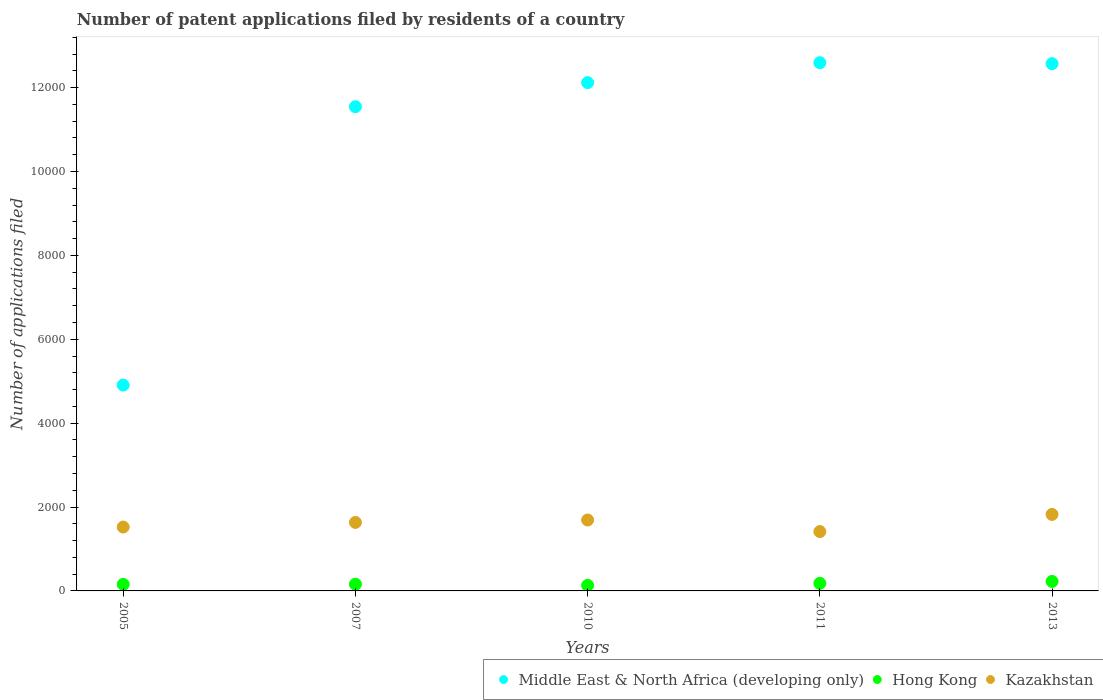How many different coloured dotlines are there?
Keep it short and to the point. 3. What is the number of applications filed in Middle East & North Africa (developing only) in 2011?
Your answer should be very brief. 1.26e+04. Across all years, what is the maximum number of applications filed in Kazakhstan?
Keep it short and to the point. 1824. Across all years, what is the minimum number of applications filed in Kazakhstan?
Keep it short and to the point. 1415. In which year was the number of applications filed in Kazakhstan minimum?
Provide a short and direct response. 2011. What is the total number of applications filed in Hong Kong in the graph?
Ensure brevity in your answer.  856. What is the difference between the number of applications filed in Middle East & North Africa (developing only) in 2013 and the number of applications filed in Hong Kong in 2005?
Provide a succinct answer. 1.24e+04. What is the average number of applications filed in Middle East & North Africa (developing only) per year?
Your answer should be very brief. 1.07e+04. In the year 2007, what is the difference between the number of applications filed in Kazakhstan and number of applications filed in Hong Kong?
Offer a terse response. 1473. What is the ratio of the number of applications filed in Hong Kong in 2010 to that in 2013?
Your answer should be very brief. 0.59. Is the number of applications filed in Middle East & North Africa (developing only) in 2007 less than that in 2011?
Your response must be concise. Yes. What is the difference between the highest and the second highest number of applications filed in Kazakhstan?
Provide a succinct answer. 133. What is the difference between the highest and the lowest number of applications filed in Middle East & North Africa (developing only)?
Provide a succinct answer. 7686. Is the sum of the number of applications filed in Hong Kong in 2011 and 2013 greater than the maximum number of applications filed in Kazakhstan across all years?
Your answer should be compact. No. Is the number of applications filed in Kazakhstan strictly greater than the number of applications filed in Hong Kong over the years?
Make the answer very short. Yes. Is the number of applications filed in Middle East & North Africa (developing only) strictly less than the number of applications filed in Hong Kong over the years?
Your answer should be compact. No. How many years are there in the graph?
Your answer should be very brief. 5. Are the values on the major ticks of Y-axis written in scientific E-notation?
Keep it short and to the point. No. Does the graph contain any zero values?
Your answer should be compact. No. Does the graph contain grids?
Your answer should be compact. No. Where does the legend appear in the graph?
Your answer should be compact. Bottom right. How many legend labels are there?
Make the answer very short. 3. How are the legend labels stacked?
Give a very brief answer. Horizontal. What is the title of the graph?
Provide a succinct answer. Number of patent applications filed by residents of a country. What is the label or title of the Y-axis?
Ensure brevity in your answer.  Number of applications filed. What is the Number of applications filed of Middle East & North Africa (developing only) in 2005?
Ensure brevity in your answer.  4908. What is the Number of applications filed in Hong Kong in 2005?
Your answer should be compact. 156. What is the Number of applications filed of Kazakhstan in 2005?
Your answer should be compact. 1523. What is the Number of applications filed of Middle East & North Africa (developing only) in 2007?
Keep it short and to the point. 1.15e+04. What is the Number of applications filed in Hong Kong in 2007?
Ensure brevity in your answer.  160. What is the Number of applications filed of Kazakhstan in 2007?
Offer a terse response. 1633. What is the Number of applications filed in Middle East & North Africa (developing only) in 2010?
Make the answer very short. 1.21e+04. What is the Number of applications filed in Hong Kong in 2010?
Provide a succinct answer. 133. What is the Number of applications filed in Kazakhstan in 2010?
Ensure brevity in your answer.  1691. What is the Number of applications filed in Middle East & North Africa (developing only) in 2011?
Provide a short and direct response. 1.26e+04. What is the Number of applications filed of Hong Kong in 2011?
Your answer should be compact. 181. What is the Number of applications filed in Kazakhstan in 2011?
Give a very brief answer. 1415. What is the Number of applications filed of Middle East & North Africa (developing only) in 2013?
Give a very brief answer. 1.26e+04. What is the Number of applications filed of Hong Kong in 2013?
Your answer should be compact. 226. What is the Number of applications filed in Kazakhstan in 2013?
Your answer should be very brief. 1824. Across all years, what is the maximum Number of applications filed of Middle East & North Africa (developing only)?
Provide a succinct answer. 1.26e+04. Across all years, what is the maximum Number of applications filed of Hong Kong?
Your answer should be compact. 226. Across all years, what is the maximum Number of applications filed of Kazakhstan?
Provide a short and direct response. 1824. Across all years, what is the minimum Number of applications filed in Middle East & North Africa (developing only)?
Offer a terse response. 4908. Across all years, what is the minimum Number of applications filed of Hong Kong?
Keep it short and to the point. 133. Across all years, what is the minimum Number of applications filed of Kazakhstan?
Make the answer very short. 1415. What is the total Number of applications filed in Middle East & North Africa (developing only) in the graph?
Your response must be concise. 5.37e+04. What is the total Number of applications filed of Hong Kong in the graph?
Provide a short and direct response. 856. What is the total Number of applications filed of Kazakhstan in the graph?
Make the answer very short. 8086. What is the difference between the Number of applications filed in Middle East & North Africa (developing only) in 2005 and that in 2007?
Provide a short and direct response. -6636. What is the difference between the Number of applications filed in Kazakhstan in 2005 and that in 2007?
Ensure brevity in your answer.  -110. What is the difference between the Number of applications filed of Middle East & North Africa (developing only) in 2005 and that in 2010?
Ensure brevity in your answer.  -7211. What is the difference between the Number of applications filed of Kazakhstan in 2005 and that in 2010?
Make the answer very short. -168. What is the difference between the Number of applications filed of Middle East & North Africa (developing only) in 2005 and that in 2011?
Provide a short and direct response. -7686. What is the difference between the Number of applications filed of Kazakhstan in 2005 and that in 2011?
Make the answer very short. 108. What is the difference between the Number of applications filed of Middle East & North Africa (developing only) in 2005 and that in 2013?
Your answer should be compact. -7663. What is the difference between the Number of applications filed of Hong Kong in 2005 and that in 2013?
Your response must be concise. -70. What is the difference between the Number of applications filed of Kazakhstan in 2005 and that in 2013?
Provide a succinct answer. -301. What is the difference between the Number of applications filed in Middle East & North Africa (developing only) in 2007 and that in 2010?
Ensure brevity in your answer.  -575. What is the difference between the Number of applications filed in Kazakhstan in 2007 and that in 2010?
Your answer should be very brief. -58. What is the difference between the Number of applications filed in Middle East & North Africa (developing only) in 2007 and that in 2011?
Provide a succinct answer. -1050. What is the difference between the Number of applications filed of Kazakhstan in 2007 and that in 2011?
Keep it short and to the point. 218. What is the difference between the Number of applications filed in Middle East & North Africa (developing only) in 2007 and that in 2013?
Provide a short and direct response. -1027. What is the difference between the Number of applications filed of Hong Kong in 2007 and that in 2013?
Your answer should be compact. -66. What is the difference between the Number of applications filed of Kazakhstan in 2007 and that in 2013?
Ensure brevity in your answer.  -191. What is the difference between the Number of applications filed of Middle East & North Africa (developing only) in 2010 and that in 2011?
Offer a very short reply. -475. What is the difference between the Number of applications filed in Hong Kong in 2010 and that in 2011?
Ensure brevity in your answer.  -48. What is the difference between the Number of applications filed in Kazakhstan in 2010 and that in 2011?
Provide a succinct answer. 276. What is the difference between the Number of applications filed of Middle East & North Africa (developing only) in 2010 and that in 2013?
Provide a short and direct response. -452. What is the difference between the Number of applications filed in Hong Kong in 2010 and that in 2013?
Give a very brief answer. -93. What is the difference between the Number of applications filed in Kazakhstan in 2010 and that in 2013?
Make the answer very short. -133. What is the difference between the Number of applications filed of Middle East & North Africa (developing only) in 2011 and that in 2013?
Ensure brevity in your answer.  23. What is the difference between the Number of applications filed in Hong Kong in 2011 and that in 2013?
Provide a short and direct response. -45. What is the difference between the Number of applications filed in Kazakhstan in 2011 and that in 2013?
Provide a short and direct response. -409. What is the difference between the Number of applications filed of Middle East & North Africa (developing only) in 2005 and the Number of applications filed of Hong Kong in 2007?
Give a very brief answer. 4748. What is the difference between the Number of applications filed in Middle East & North Africa (developing only) in 2005 and the Number of applications filed in Kazakhstan in 2007?
Your answer should be compact. 3275. What is the difference between the Number of applications filed of Hong Kong in 2005 and the Number of applications filed of Kazakhstan in 2007?
Provide a succinct answer. -1477. What is the difference between the Number of applications filed of Middle East & North Africa (developing only) in 2005 and the Number of applications filed of Hong Kong in 2010?
Make the answer very short. 4775. What is the difference between the Number of applications filed in Middle East & North Africa (developing only) in 2005 and the Number of applications filed in Kazakhstan in 2010?
Provide a short and direct response. 3217. What is the difference between the Number of applications filed of Hong Kong in 2005 and the Number of applications filed of Kazakhstan in 2010?
Your answer should be compact. -1535. What is the difference between the Number of applications filed of Middle East & North Africa (developing only) in 2005 and the Number of applications filed of Hong Kong in 2011?
Keep it short and to the point. 4727. What is the difference between the Number of applications filed in Middle East & North Africa (developing only) in 2005 and the Number of applications filed in Kazakhstan in 2011?
Provide a succinct answer. 3493. What is the difference between the Number of applications filed in Hong Kong in 2005 and the Number of applications filed in Kazakhstan in 2011?
Your response must be concise. -1259. What is the difference between the Number of applications filed in Middle East & North Africa (developing only) in 2005 and the Number of applications filed in Hong Kong in 2013?
Your answer should be compact. 4682. What is the difference between the Number of applications filed in Middle East & North Africa (developing only) in 2005 and the Number of applications filed in Kazakhstan in 2013?
Ensure brevity in your answer.  3084. What is the difference between the Number of applications filed in Hong Kong in 2005 and the Number of applications filed in Kazakhstan in 2013?
Give a very brief answer. -1668. What is the difference between the Number of applications filed in Middle East & North Africa (developing only) in 2007 and the Number of applications filed in Hong Kong in 2010?
Provide a succinct answer. 1.14e+04. What is the difference between the Number of applications filed of Middle East & North Africa (developing only) in 2007 and the Number of applications filed of Kazakhstan in 2010?
Provide a short and direct response. 9853. What is the difference between the Number of applications filed of Hong Kong in 2007 and the Number of applications filed of Kazakhstan in 2010?
Offer a terse response. -1531. What is the difference between the Number of applications filed of Middle East & North Africa (developing only) in 2007 and the Number of applications filed of Hong Kong in 2011?
Your answer should be compact. 1.14e+04. What is the difference between the Number of applications filed of Middle East & North Africa (developing only) in 2007 and the Number of applications filed of Kazakhstan in 2011?
Provide a short and direct response. 1.01e+04. What is the difference between the Number of applications filed of Hong Kong in 2007 and the Number of applications filed of Kazakhstan in 2011?
Offer a terse response. -1255. What is the difference between the Number of applications filed of Middle East & North Africa (developing only) in 2007 and the Number of applications filed of Hong Kong in 2013?
Provide a succinct answer. 1.13e+04. What is the difference between the Number of applications filed of Middle East & North Africa (developing only) in 2007 and the Number of applications filed of Kazakhstan in 2013?
Give a very brief answer. 9720. What is the difference between the Number of applications filed in Hong Kong in 2007 and the Number of applications filed in Kazakhstan in 2013?
Offer a terse response. -1664. What is the difference between the Number of applications filed in Middle East & North Africa (developing only) in 2010 and the Number of applications filed in Hong Kong in 2011?
Your answer should be very brief. 1.19e+04. What is the difference between the Number of applications filed of Middle East & North Africa (developing only) in 2010 and the Number of applications filed of Kazakhstan in 2011?
Offer a very short reply. 1.07e+04. What is the difference between the Number of applications filed in Hong Kong in 2010 and the Number of applications filed in Kazakhstan in 2011?
Ensure brevity in your answer.  -1282. What is the difference between the Number of applications filed in Middle East & North Africa (developing only) in 2010 and the Number of applications filed in Hong Kong in 2013?
Give a very brief answer. 1.19e+04. What is the difference between the Number of applications filed of Middle East & North Africa (developing only) in 2010 and the Number of applications filed of Kazakhstan in 2013?
Offer a very short reply. 1.03e+04. What is the difference between the Number of applications filed of Hong Kong in 2010 and the Number of applications filed of Kazakhstan in 2013?
Ensure brevity in your answer.  -1691. What is the difference between the Number of applications filed of Middle East & North Africa (developing only) in 2011 and the Number of applications filed of Hong Kong in 2013?
Your response must be concise. 1.24e+04. What is the difference between the Number of applications filed of Middle East & North Africa (developing only) in 2011 and the Number of applications filed of Kazakhstan in 2013?
Your answer should be very brief. 1.08e+04. What is the difference between the Number of applications filed of Hong Kong in 2011 and the Number of applications filed of Kazakhstan in 2013?
Provide a short and direct response. -1643. What is the average Number of applications filed in Middle East & North Africa (developing only) per year?
Your answer should be compact. 1.07e+04. What is the average Number of applications filed in Hong Kong per year?
Offer a very short reply. 171.2. What is the average Number of applications filed of Kazakhstan per year?
Provide a succinct answer. 1617.2. In the year 2005, what is the difference between the Number of applications filed in Middle East & North Africa (developing only) and Number of applications filed in Hong Kong?
Keep it short and to the point. 4752. In the year 2005, what is the difference between the Number of applications filed of Middle East & North Africa (developing only) and Number of applications filed of Kazakhstan?
Your answer should be compact. 3385. In the year 2005, what is the difference between the Number of applications filed in Hong Kong and Number of applications filed in Kazakhstan?
Provide a short and direct response. -1367. In the year 2007, what is the difference between the Number of applications filed in Middle East & North Africa (developing only) and Number of applications filed in Hong Kong?
Give a very brief answer. 1.14e+04. In the year 2007, what is the difference between the Number of applications filed of Middle East & North Africa (developing only) and Number of applications filed of Kazakhstan?
Your answer should be very brief. 9911. In the year 2007, what is the difference between the Number of applications filed of Hong Kong and Number of applications filed of Kazakhstan?
Keep it short and to the point. -1473. In the year 2010, what is the difference between the Number of applications filed in Middle East & North Africa (developing only) and Number of applications filed in Hong Kong?
Offer a very short reply. 1.20e+04. In the year 2010, what is the difference between the Number of applications filed of Middle East & North Africa (developing only) and Number of applications filed of Kazakhstan?
Give a very brief answer. 1.04e+04. In the year 2010, what is the difference between the Number of applications filed of Hong Kong and Number of applications filed of Kazakhstan?
Provide a succinct answer. -1558. In the year 2011, what is the difference between the Number of applications filed in Middle East & North Africa (developing only) and Number of applications filed in Hong Kong?
Make the answer very short. 1.24e+04. In the year 2011, what is the difference between the Number of applications filed of Middle East & North Africa (developing only) and Number of applications filed of Kazakhstan?
Your response must be concise. 1.12e+04. In the year 2011, what is the difference between the Number of applications filed in Hong Kong and Number of applications filed in Kazakhstan?
Provide a succinct answer. -1234. In the year 2013, what is the difference between the Number of applications filed of Middle East & North Africa (developing only) and Number of applications filed of Hong Kong?
Provide a short and direct response. 1.23e+04. In the year 2013, what is the difference between the Number of applications filed in Middle East & North Africa (developing only) and Number of applications filed in Kazakhstan?
Provide a succinct answer. 1.07e+04. In the year 2013, what is the difference between the Number of applications filed in Hong Kong and Number of applications filed in Kazakhstan?
Offer a terse response. -1598. What is the ratio of the Number of applications filed in Middle East & North Africa (developing only) in 2005 to that in 2007?
Keep it short and to the point. 0.43. What is the ratio of the Number of applications filed in Kazakhstan in 2005 to that in 2007?
Provide a short and direct response. 0.93. What is the ratio of the Number of applications filed in Middle East & North Africa (developing only) in 2005 to that in 2010?
Offer a very short reply. 0.41. What is the ratio of the Number of applications filed of Hong Kong in 2005 to that in 2010?
Your answer should be compact. 1.17. What is the ratio of the Number of applications filed in Kazakhstan in 2005 to that in 2010?
Your answer should be very brief. 0.9. What is the ratio of the Number of applications filed of Middle East & North Africa (developing only) in 2005 to that in 2011?
Give a very brief answer. 0.39. What is the ratio of the Number of applications filed in Hong Kong in 2005 to that in 2011?
Provide a succinct answer. 0.86. What is the ratio of the Number of applications filed of Kazakhstan in 2005 to that in 2011?
Make the answer very short. 1.08. What is the ratio of the Number of applications filed of Middle East & North Africa (developing only) in 2005 to that in 2013?
Offer a terse response. 0.39. What is the ratio of the Number of applications filed of Hong Kong in 2005 to that in 2013?
Your answer should be very brief. 0.69. What is the ratio of the Number of applications filed in Kazakhstan in 2005 to that in 2013?
Offer a very short reply. 0.83. What is the ratio of the Number of applications filed in Middle East & North Africa (developing only) in 2007 to that in 2010?
Provide a short and direct response. 0.95. What is the ratio of the Number of applications filed in Hong Kong in 2007 to that in 2010?
Give a very brief answer. 1.2. What is the ratio of the Number of applications filed of Kazakhstan in 2007 to that in 2010?
Offer a very short reply. 0.97. What is the ratio of the Number of applications filed in Middle East & North Africa (developing only) in 2007 to that in 2011?
Keep it short and to the point. 0.92. What is the ratio of the Number of applications filed of Hong Kong in 2007 to that in 2011?
Keep it short and to the point. 0.88. What is the ratio of the Number of applications filed of Kazakhstan in 2007 to that in 2011?
Make the answer very short. 1.15. What is the ratio of the Number of applications filed of Middle East & North Africa (developing only) in 2007 to that in 2013?
Make the answer very short. 0.92. What is the ratio of the Number of applications filed in Hong Kong in 2007 to that in 2013?
Give a very brief answer. 0.71. What is the ratio of the Number of applications filed of Kazakhstan in 2007 to that in 2013?
Give a very brief answer. 0.9. What is the ratio of the Number of applications filed of Middle East & North Africa (developing only) in 2010 to that in 2011?
Provide a short and direct response. 0.96. What is the ratio of the Number of applications filed of Hong Kong in 2010 to that in 2011?
Ensure brevity in your answer.  0.73. What is the ratio of the Number of applications filed in Kazakhstan in 2010 to that in 2011?
Your answer should be very brief. 1.2. What is the ratio of the Number of applications filed in Hong Kong in 2010 to that in 2013?
Provide a short and direct response. 0.59. What is the ratio of the Number of applications filed of Kazakhstan in 2010 to that in 2013?
Your response must be concise. 0.93. What is the ratio of the Number of applications filed in Middle East & North Africa (developing only) in 2011 to that in 2013?
Keep it short and to the point. 1. What is the ratio of the Number of applications filed in Hong Kong in 2011 to that in 2013?
Offer a very short reply. 0.8. What is the ratio of the Number of applications filed in Kazakhstan in 2011 to that in 2013?
Offer a terse response. 0.78. What is the difference between the highest and the second highest Number of applications filed in Hong Kong?
Keep it short and to the point. 45. What is the difference between the highest and the second highest Number of applications filed in Kazakhstan?
Your answer should be very brief. 133. What is the difference between the highest and the lowest Number of applications filed in Middle East & North Africa (developing only)?
Offer a terse response. 7686. What is the difference between the highest and the lowest Number of applications filed in Hong Kong?
Your response must be concise. 93. What is the difference between the highest and the lowest Number of applications filed of Kazakhstan?
Your response must be concise. 409. 